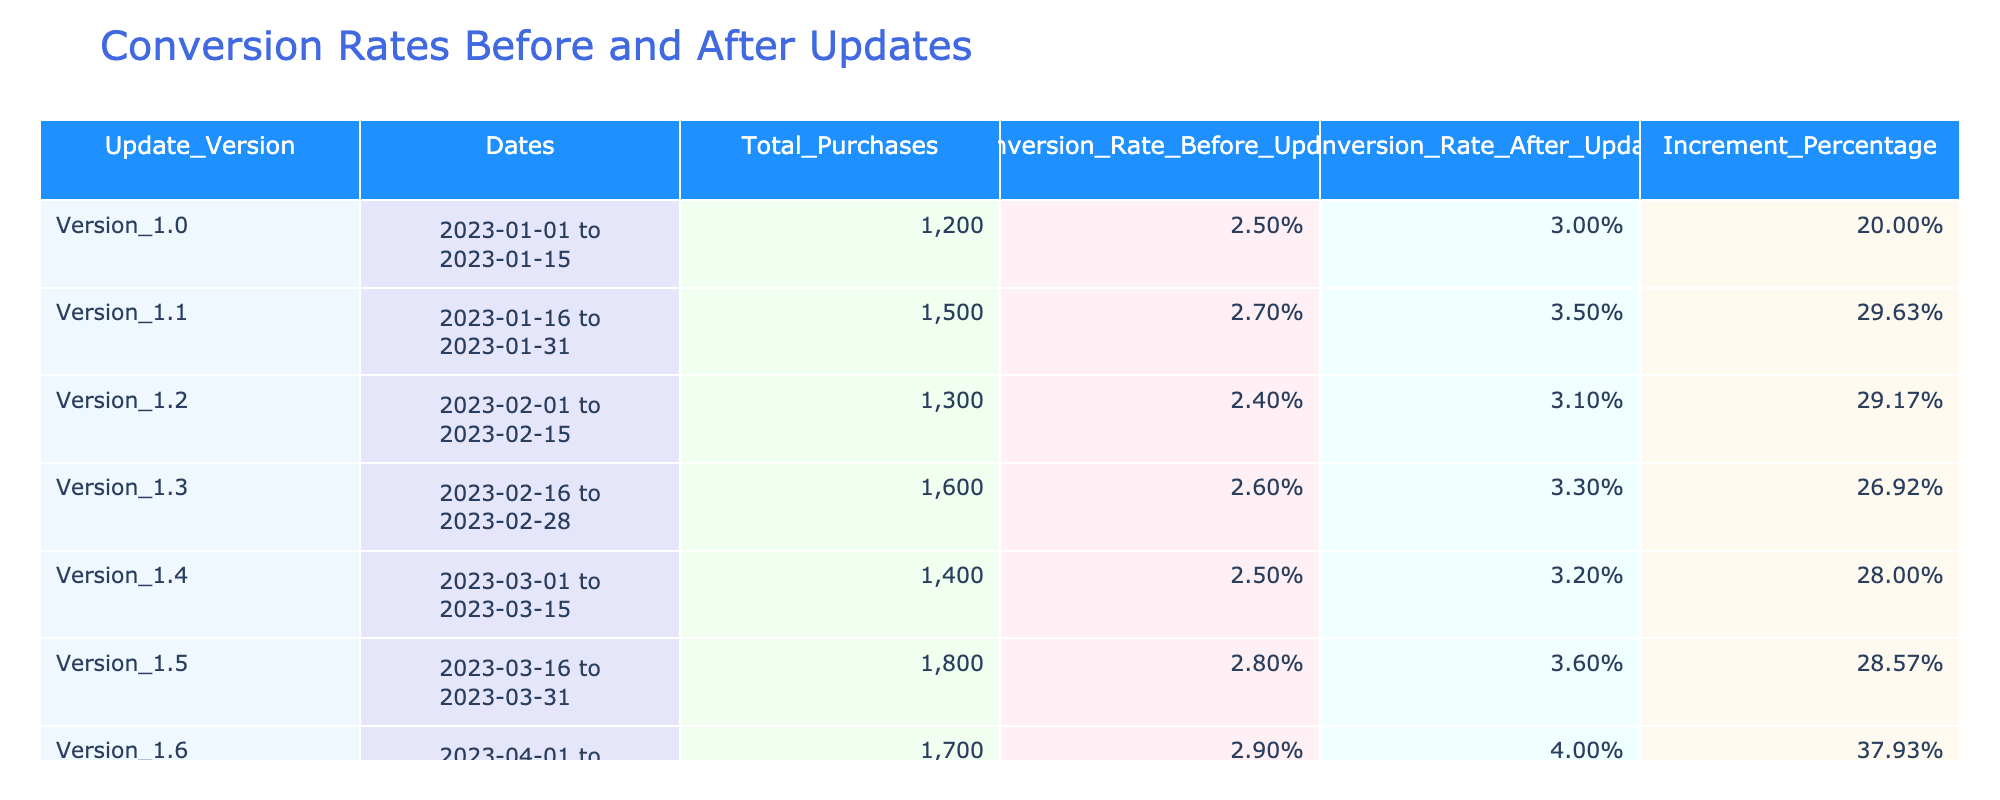What was the total number of purchases in Version 1.4? In the row for Version 1.4, the column "Total_Purchases" shows a value of 1400.
Answer: 1400 What is the conversion rate after the update for Version 1.2? In the row for Version 1.2, the column "Conversion_Rate_After_Update" shows a value of 3.1%.
Answer: 3.1% Which version had the highest increment percentage in conversion rate? By examining the "Increment_Percentage" column, Version 1.6 has the highest increment at 37.93%.
Answer: Version 1.6 Is the conversion rate after the update for Version 1.5 higher than the conversion rate before the update for Version 1.5? The conversion rate after the update for Version 1.5 is 3.6%, and the before update rate is 2.8%. Since 3.6% is greater than 2.8%, the statement is true.
Answer: Yes What is the average conversion rate before the update across all versions? To find the average, add up the conversion rates before the update: 2.5% + 2.7% + 2.4% + 2.6% + 2.5% + 2.8% + 2.9% = 17.4%. There are 7 versions, so divide by 7, giving an average of approximately 2.49%.
Answer: 2.49% How many versions had a conversion rate after the update of 3% or more? Checking the "Conversion_Rate_After_Update" column, Versions 1.1, 1.2, 1.3, 1.4, 1.5, and 1.6 have rates of 3.5%, 3.1%, 3.3%, 3.2%, 3.6%, and 4.0%, respectively, totaling 6 versions.
Answer: 6 Did the conversion rate before the update decrease in any version compared to the previous version? Comparing the conversion rates before updates: Version 1.1 (2.7%) is greater than Version 1.0 (2.5%), Version 1.2 (2.4%) is lower than Version 1.1, but the rest either increased or stayed the same. So, yes, there was a decrease.
Answer: Yes What was the conversion rate before the update for the version with the highest total purchases? Reviewing the total purchases, Version 1.5 has the highest total of 1800 purchases, with a conversion rate before the update of 2.8%.
Answer: 2.8% Which update version had the largest difference between the conversion rates before and after the update? To find the largest difference, calculate the difference for each version: Version 1.0: 0.5%, Version 1.1: 0.8%, Version 1.2: 0.7%, Version 1.3: 0.7%, Version 1.4: 0.7%, Version 1.5: 0.8%, Version 1.6: 1.1%. The largest difference is for Version 1.6 at 1.1%.
Answer: Version 1.6 